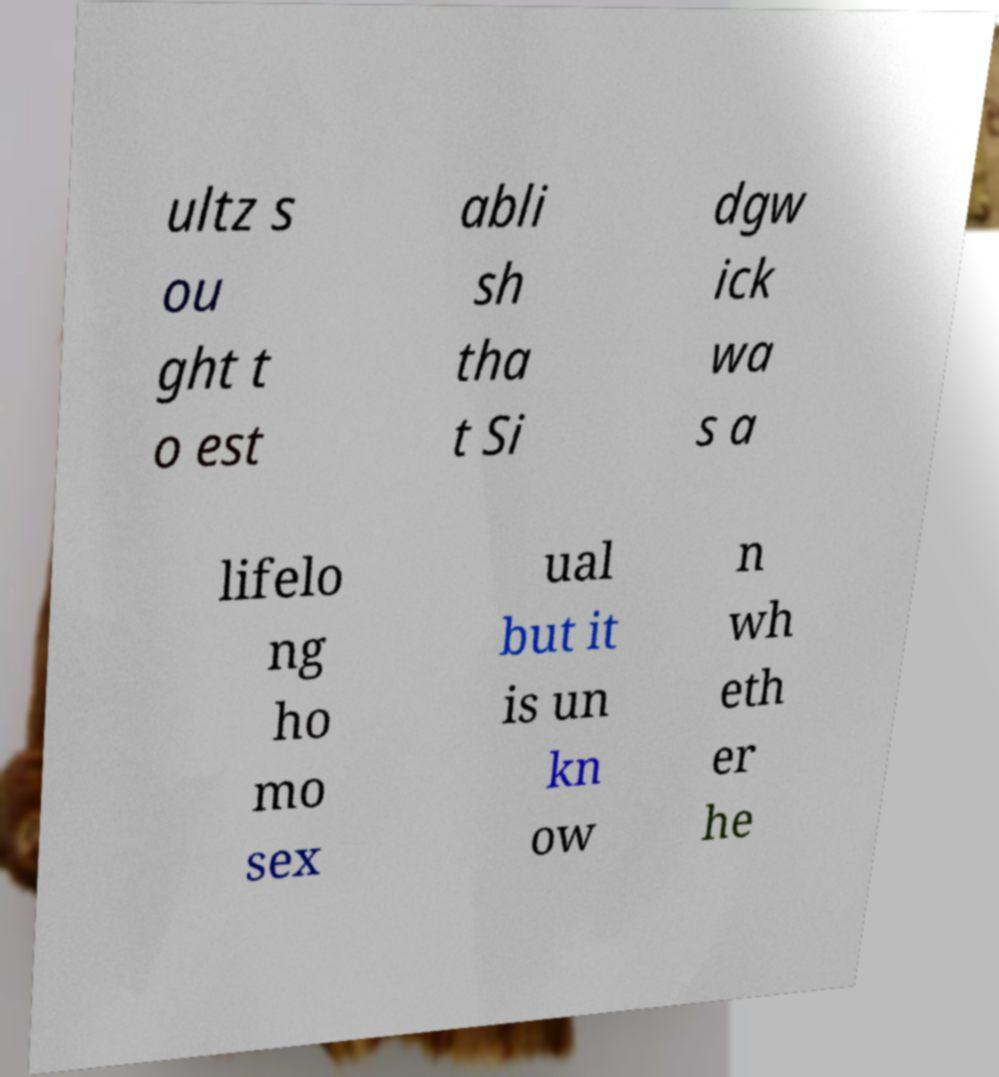Can you accurately transcribe the text from the provided image for me? ultz s ou ght t o est abli sh tha t Si dgw ick wa s a lifelo ng ho mo sex ual but it is un kn ow n wh eth er he 